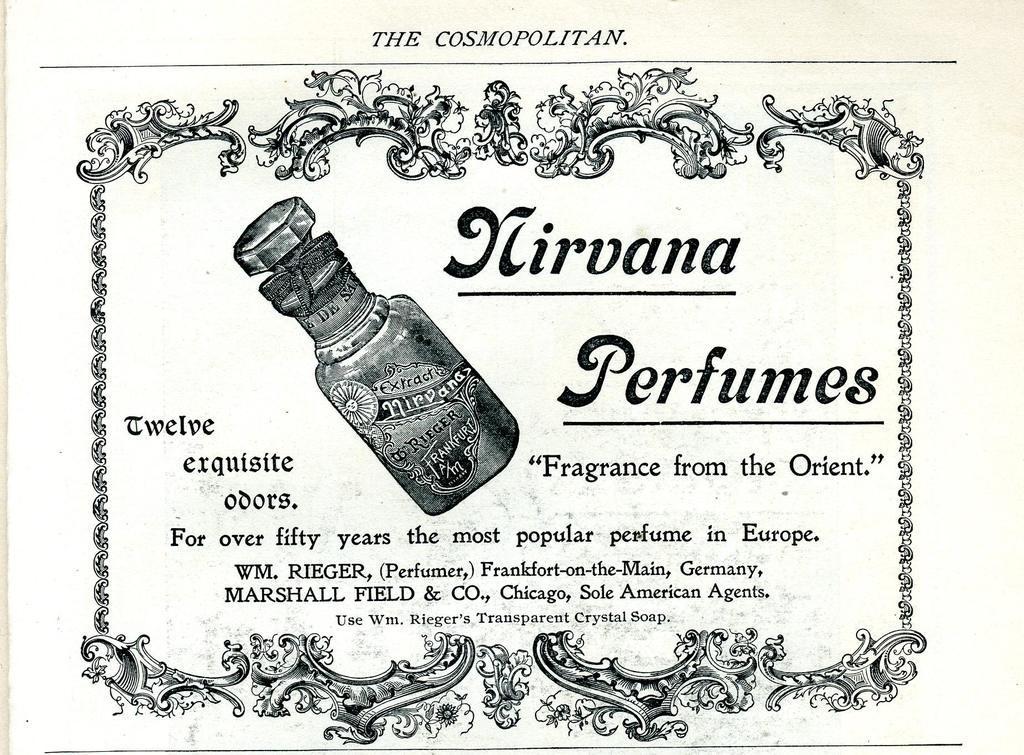Could you give a brief overview of what you see in this image? In this image we can see a paper. In the paper there are bottle printed on it, some text and a design to the borders. 